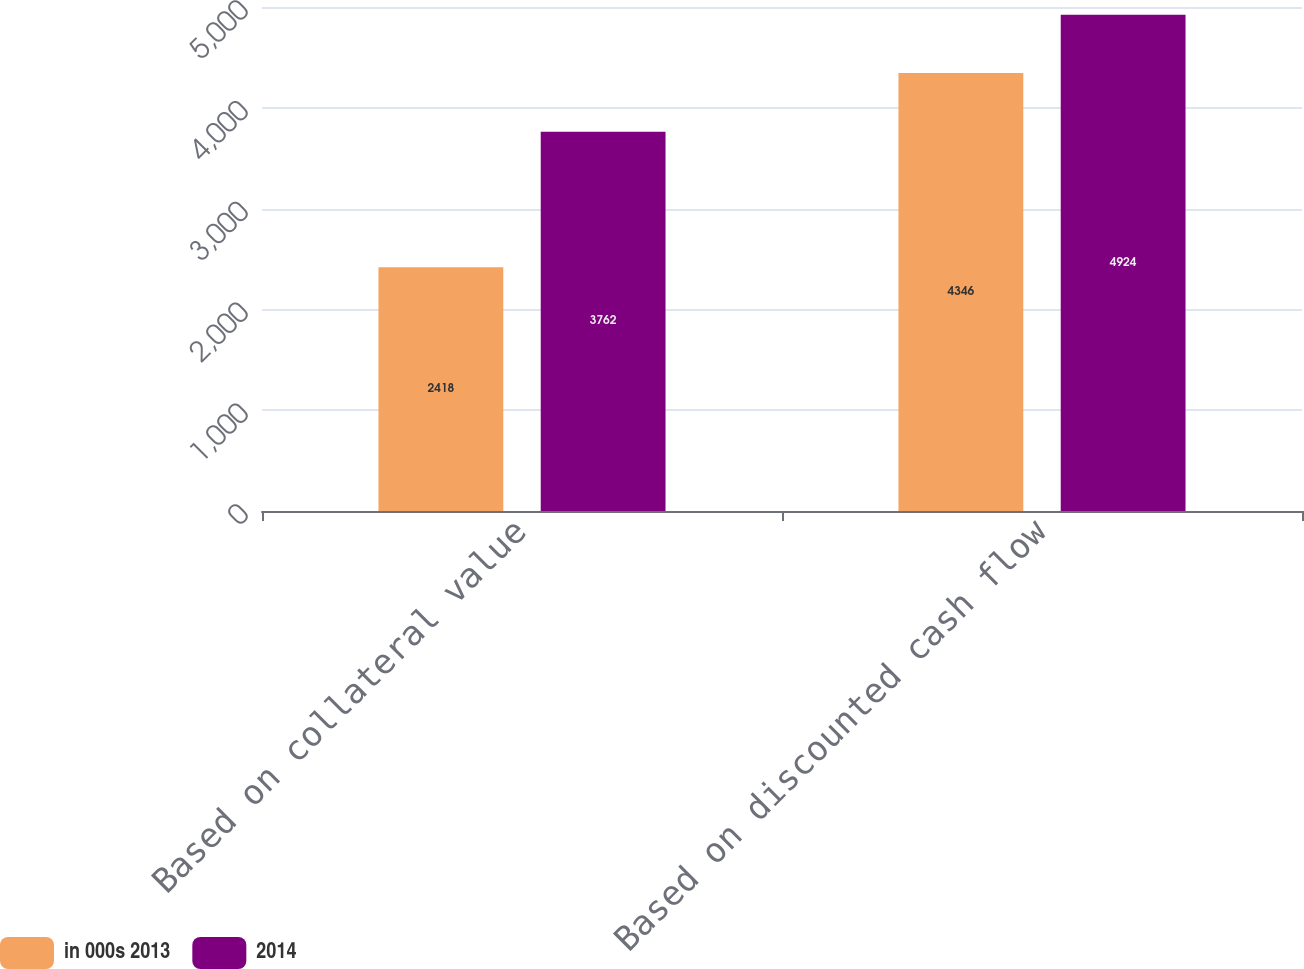<chart> <loc_0><loc_0><loc_500><loc_500><stacked_bar_chart><ecel><fcel>Based on collateral value<fcel>Based on discounted cash flow<nl><fcel>in 000s 2013<fcel>2418<fcel>4346<nl><fcel>2014<fcel>3762<fcel>4924<nl></chart> 